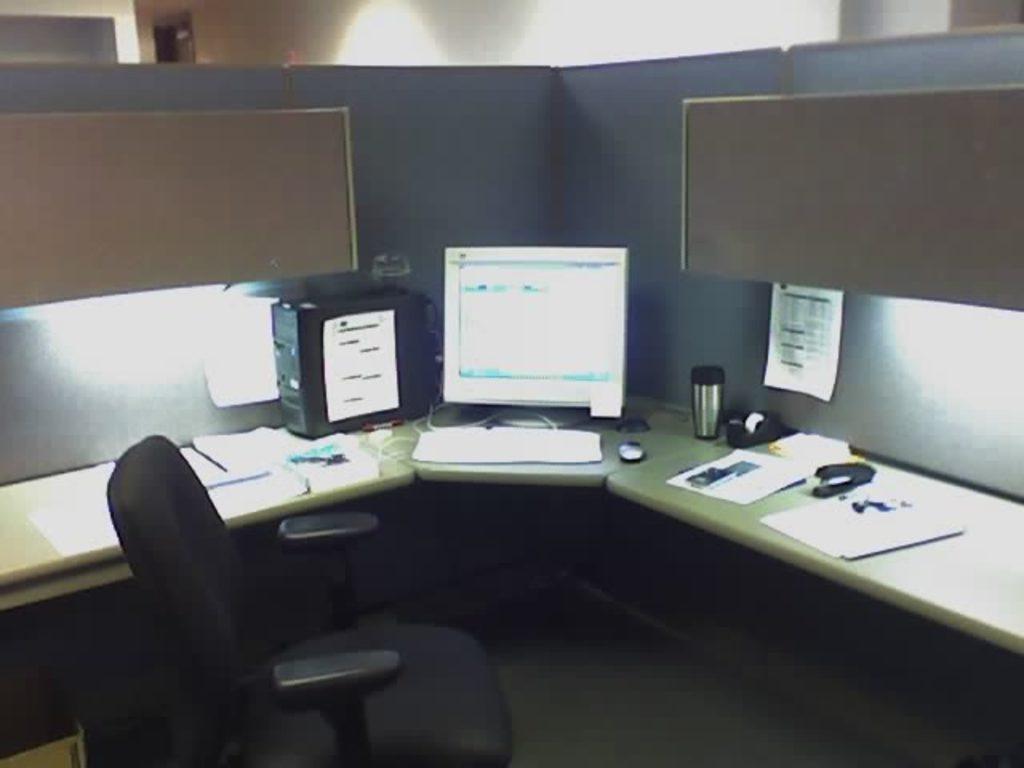Can you describe this image briefly? In this image, we can see a desk contains computer, papers, flask, tape and stapler. There is a chair at the bottom of the image. There is board in the top left and in the top right of the image. 